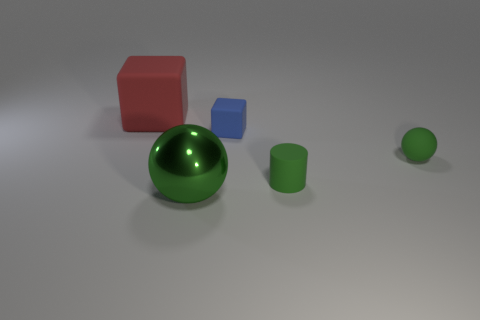Add 2 big cyan rubber things. How many objects exist? 7 Subtract all balls. How many objects are left? 3 Add 3 shiny spheres. How many shiny spheres exist? 4 Subtract 0 cyan balls. How many objects are left? 5 Subtract all big gray cylinders. Subtract all red rubber objects. How many objects are left? 4 Add 4 small blue cubes. How many small blue cubes are left? 5 